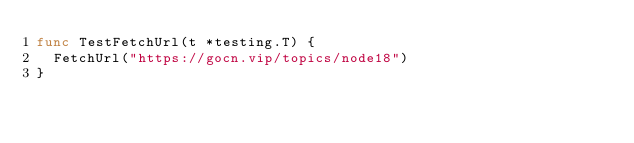Convert code to text. <code><loc_0><loc_0><loc_500><loc_500><_Go_>func TestFetchUrl(t *testing.T) {
	FetchUrl("https://gocn.vip/topics/node18")
}
</code> 